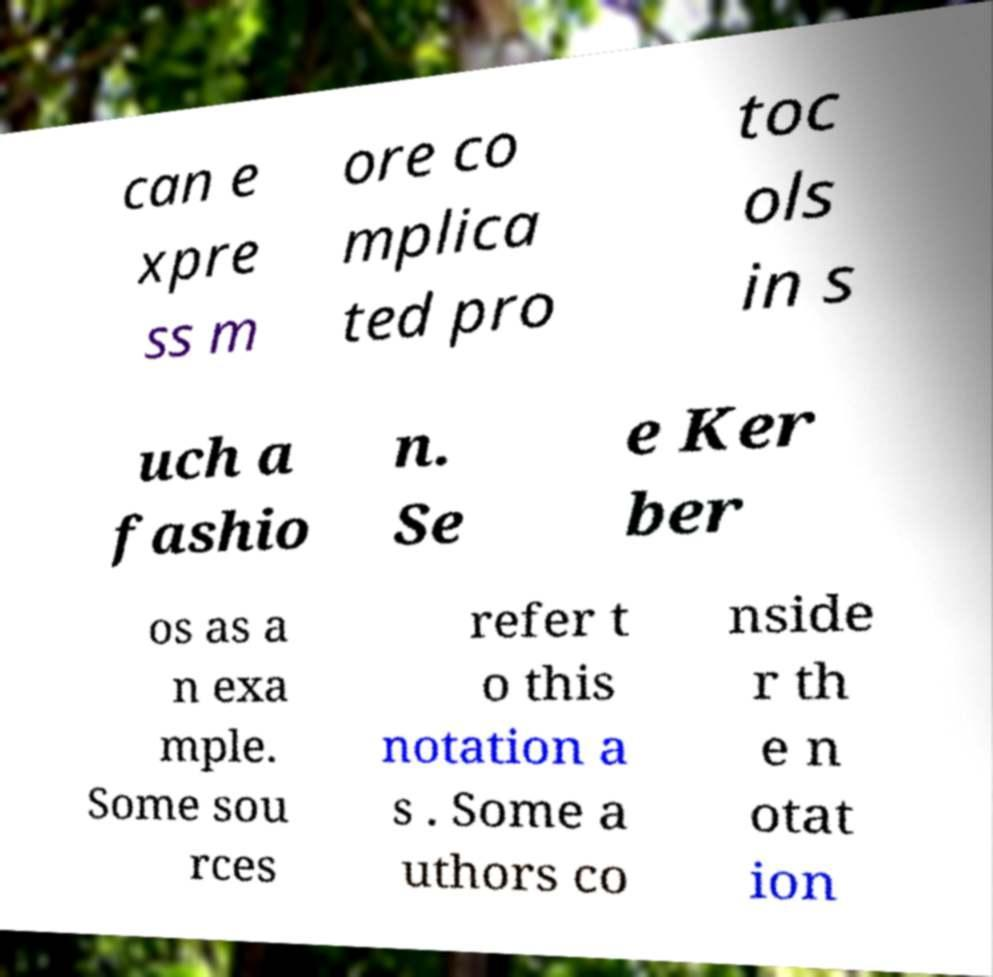Can you accurately transcribe the text from the provided image for me? can e xpre ss m ore co mplica ted pro toc ols in s uch a fashio n. Se e Ker ber os as a n exa mple. Some sou rces refer t o this notation a s . Some a uthors co nside r th e n otat ion 